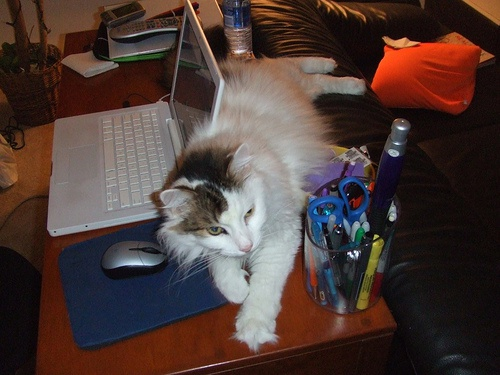Describe the objects in this image and their specific colors. I can see couch in maroon, black, and red tones, cat in maroon, darkgray, gray, and black tones, laptop in maroon, gray, and black tones, cup in maroon, black, gray, and navy tones, and potted plant in maroon, black, and brown tones in this image. 